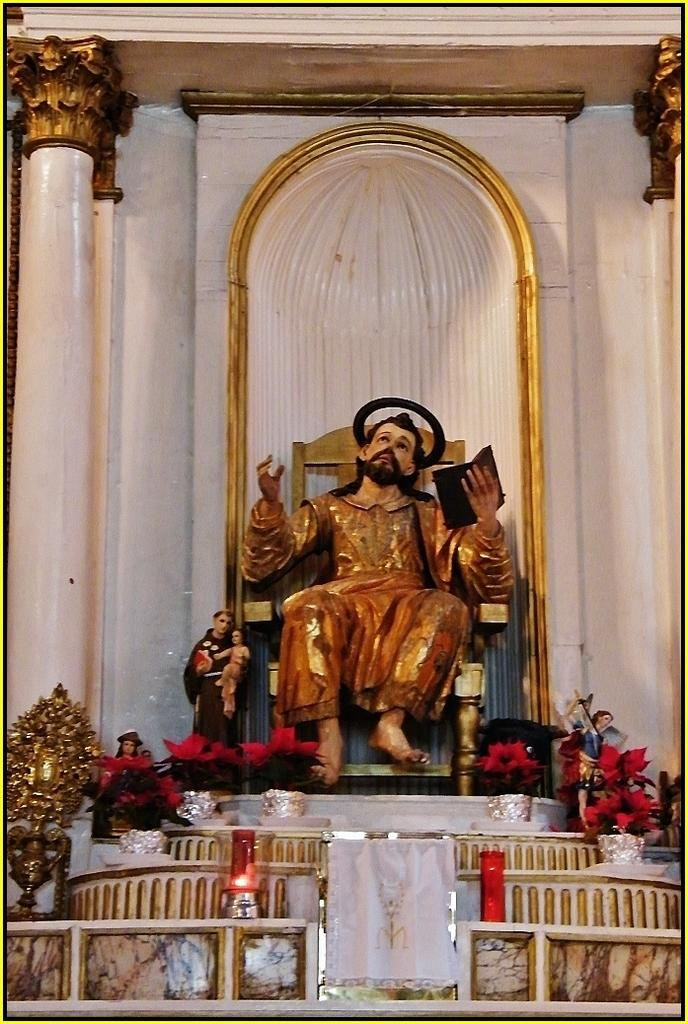What type of objects can be seen in the image? There are sculptures, flower pots, and a candle chimney in the image. What architectural elements are present in the image? There are pillars in the image. What type of window treatment is visible in the image? There is a small white curtain in the image. What type of cherries are being served on the table in the image? There is no table or cherries present in the image. What is the skin condition of the person in the image? There is no person present in the image. 